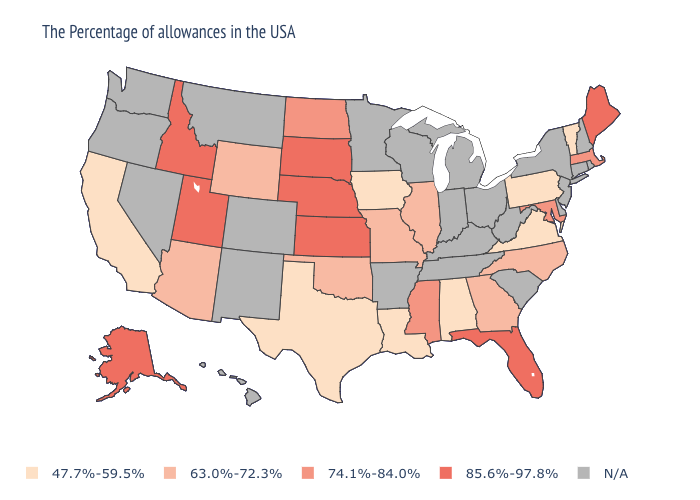What is the value of Florida?
Short answer required. 85.6%-97.8%. Which states have the highest value in the USA?
Keep it brief. Maine, Florida, Kansas, Nebraska, South Dakota, Utah, Idaho, Alaska. What is the value of Idaho?
Quick response, please. 85.6%-97.8%. Name the states that have a value in the range 47.7%-59.5%?
Quick response, please. Vermont, Pennsylvania, Virginia, Alabama, Louisiana, Iowa, Texas, California. What is the value of California?
Be succinct. 47.7%-59.5%. What is the lowest value in the USA?
Answer briefly. 47.7%-59.5%. Name the states that have a value in the range 74.1%-84.0%?
Short answer required. Massachusetts, Maryland, Mississippi, North Dakota. Among the states that border Oklahoma , does Kansas have the lowest value?
Concise answer only. No. What is the value of Montana?
Write a very short answer. N/A. What is the value of Oklahoma?
Short answer required. 63.0%-72.3%. What is the value of Utah?
Write a very short answer. 85.6%-97.8%. Name the states that have a value in the range 47.7%-59.5%?
Answer briefly. Vermont, Pennsylvania, Virginia, Alabama, Louisiana, Iowa, Texas, California. Name the states that have a value in the range N/A?
Concise answer only. Rhode Island, New Hampshire, Connecticut, New York, New Jersey, Delaware, South Carolina, West Virginia, Ohio, Michigan, Kentucky, Indiana, Tennessee, Wisconsin, Arkansas, Minnesota, Colorado, New Mexico, Montana, Nevada, Washington, Oregon, Hawaii. 